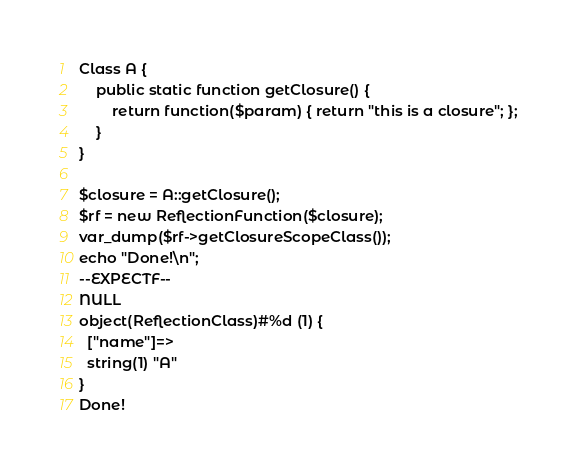<code> <loc_0><loc_0><loc_500><loc_500><_PHP_>Class A {
	public static function getClosure() {
		return function($param) { return "this is a closure"; };
	}
}

$closure = A::getClosure();
$rf = new ReflectionFunction($closure);
var_dump($rf->getClosureScopeClass());
echo "Done!\n";
--EXPECTF--
NULL
object(ReflectionClass)#%d (1) {
  ["name"]=>
  string(1) "A"
}
Done!
</code> 